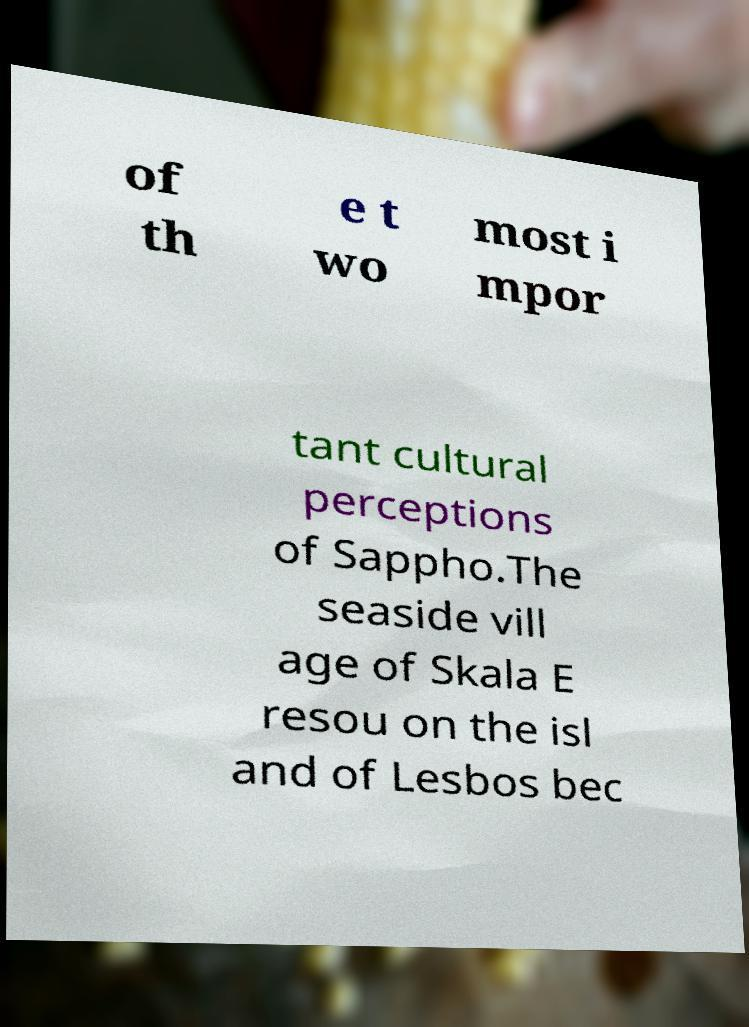Please identify and transcribe the text found in this image. of th e t wo most i mpor tant cultural perceptions of Sappho.The seaside vill age of Skala E resou on the isl and of Lesbos bec 